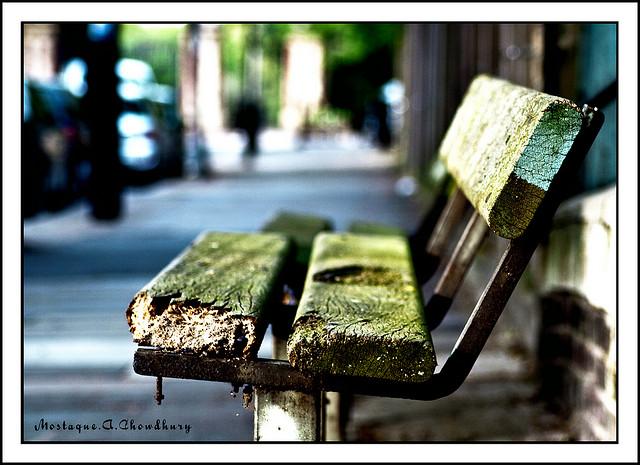What text on the picture say?
Short answer required. Montague g chaudhary. Is it day or night in the photography?
Write a very short answer. Day. Does the wood on the bench rotten?
Concise answer only. Yes. 